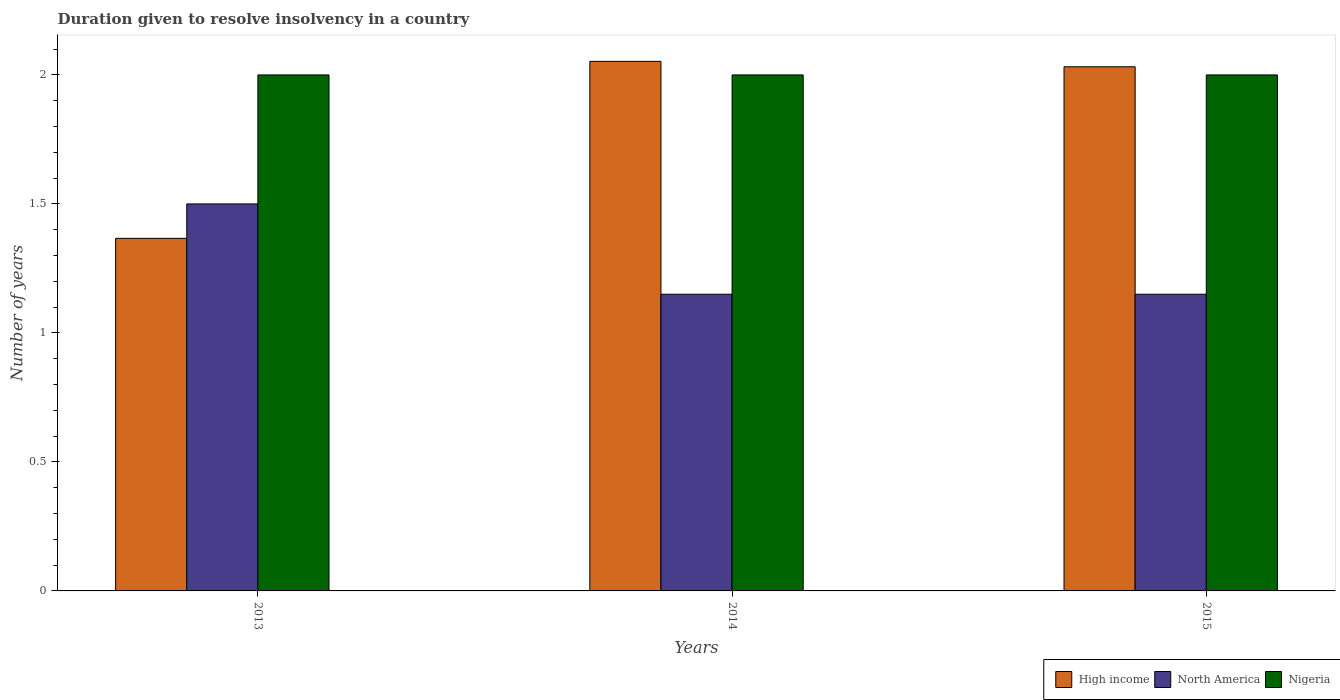How many different coloured bars are there?
Ensure brevity in your answer.  3. In how many cases, is the number of bars for a given year not equal to the number of legend labels?
Provide a succinct answer. 0. What is the duration given to resolve insolvency in in High income in 2013?
Offer a very short reply. 1.37. Across all years, what is the maximum duration given to resolve insolvency in in High income?
Offer a terse response. 2.05. Across all years, what is the minimum duration given to resolve insolvency in in North America?
Offer a terse response. 1.15. In which year was the duration given to resolve insolvency in in North America minimum?
Give a very brief answer. 2014. What is the total duration given to resolve insolvency in in Nigeria in the graph?
Offer a very short reply. 6. What is the difference between the duration given to resolve insolvency in in High income in 2013 and that in 2014?
Give a very brief answer. -0.69. What is the difference between the duration given to resolve insolvency in in North America in 2015 and the duration given to resolve insolvency in in Nigeria in 2013?
Your answer should be very brief. -0.85. What is the average duration given to resolve insolvency in in North America per year?
Keep it short and to the point. 1.27. In the year 2015, what is the difference between the duration given to resolve insolvency in in High income and duration given to resolve insolvency in in Nigeria?
Offer a terse response. 0.03. In how many years, is the duration given to resolve insolvency in in Nigeria greater than 0.9 years?
Ensure brevity in your answer.  3. What is the ratio of the duration given to resolve insolvency in in North America in 2013 to that in 2015?
Your answer should be very brief. 1.3. Is the duration given to resolve insolvency in in Nigeria in 2013 less than that in 2015?
Your answer should be compact. No. What is the difference between the highest and the second highest duration given to resolve insolvency in in High income?
Your answer should be very brief. 0.02. What is the difference between the highest and the lowest duration given to resolve insolvency in in North America?
Give a very brief answer. 0.35. Is the sum of the duration given to resolve insolvency in in High income in 2013 and 2015 greater than the maximum duration given to resolve insolvency in in Nigeria across all years?
Keep it short and to the point. Yes. What does the 2nd bar from the left in 2014 represents?
Give a very brief answer. North America. Are all the bars in the graph horizontal?
Offer a very short reply. No. How many years are there in the graph?
Your answer should be compact. 3. What is the difference between two consecutive major ticks on the Y-axis?
Make the answer very short. 0.5. Does the graph contain any zero values?
Provide a succinct answer. No. Does the graph contain grids?
Your response must be concise. No. Where does the legend appear in the graph?
Offer a terse response. Bottom right. How many legend labels are there?
Your answer should be very brief. 3. How are the legend labels stacked?
Offer a very short reply. Horizontal. What is the title of the graph?
Your answer should be very brief. Duration given to resolve insolvency in a country. What is the label or title of the X-axis?
Give a very brief answer. Years. What is the label or title of the Y-axis?
Your answer should be very brief. Number of years. What is the Number of years of High income in 2013?
Your response must be concise. 1.37. What is the Number of years of North America in 2013?
Your answer should be very brief. 1.5. What is the Number of years of High income in 2014?
Your response must be concise. 2.05. What is the Number of years in North America in 2014?
Provide a short and direct response. 1.15. What is the Number of years in Nigeria in 2014?
Your answer should be very brief. 2. What is the Number of years of High income in 2015?
Keep it short and to the point. 2.03. What is the Number of years of North America in 2015?
Provide a succinct answer. 1.15. What is the Number of years of Nigeria in 2015?
Your answer should be compact. 2. Across all years, what is the maximum Number of years of High income?
Your answer should be very brief. 2.05. Across all years, what is the maximum Number of years in North America?
Offer a very short reply. 1.5. Across all years, what is the maximum Number of years in Nigeria?
Ensure brevity in your answer.  2. Across all years, what is the minimum Number of years of High income?
Ensure brevity in your answer.  1.37. Across all years, what is the minimum Number of years of North America?
Your answer should be compact. 1.15. What is the total Number of years of High income in the graph?
Provide a short and direct response. 5.45. What is the total Number of years of North America in the graph?
Give a very brief answer. 3.8. What is the difference between the Number of years in High income in 2013 and that in 2014?
Offer a terse response. -0.69. What is the difference between the Number of years of High income in 2013 and that in 2015?
Offer a terse response. -0.66. What is the difference between the Number of years in High income in 2014 and that in 2015?
Make the answer very short. 0.02. What is the difference between the Number of years in Nigeria in 2014 and that in 2015?
Your answer should be compact. 0. What is the difference between the Number of years of High income in 2013 and the Number of years of North America in 2014?
Your answer should be compact. 0.22. What is the difference between the Number of years of High income in 2013 and the Number of years of Nigeria in 2014?
Provide a succinct answer. -0.63. What is the difference between the Number of years in North America in 2013 and the Number of years in Nigeria in 2014?
Offer a very short reply. -0.5. What is the difference between the Number of years of High income in 2013 and the Number of years of North America in 2015?
Keep it short and to the point. 0.22. What is the difference between the Number of years in High income in 2013 and the Number of years in Nigeria in 2015?
Provide a short and direct response. -0.63. What is the difference between the Number of years in High income in 2014 and the Number of years in North America in 2015?
Ensure brevity in your answer.  0.9. What is the difference between the Number of years of High income in 2014 and the Number of years of Nigeria in 2015?
Ensure brevity in your answer.  0.05. What is the difference between the Number of years of North America in 2014 and the Number of years of Nigeria in 2015?
Your response must be concise. -0.85. What is the average Number of years in High income per year?
Give a very brief answer. 1.82. What is the average Number of years of North America per year?
Make the answer very short. 1.27. What is the average Number of years of Nigeria per year?
Make the answer very short. 2. In the year 2013, what is the difference between the Number of years of High income and Number of years of North America?
Provide a short and direct response. -0.13. In the year 2013, what is the difference between the Number of years of High income and Number of years of Nigeria?
Keep it short and to the point. -0.63. In the year 2013, what is the difference between the Number of years of North America and Number of years of Nigeria?
Ensure brevity in your answer.  -0.5. In the year 2014, what is the difference between the Number of years of High income and Number of years of North America?
Offer a very short reply. 0.9. In the year 2014, what is the difference between the Number of years of High income and Number of years of Nigeria?
Give a very brief answer. 0.05. In the year 2014, what is the difference between the Number of years in North America and Number of years in Nigeria?
Provide a short and direct response. -0.85. In the year 2015, what is the difference between the Number of years of High income and Number of years of North America?
Offer a terse response. 0.88. In the year 2015, what is the difference between the Number of years in High income and Number of years in Nigeria?
Provide a short and direct response. 0.03. In the year 2015, what is the difference between the Number of years in North America and Number of years in Nigeria?
Provide a short and direct response. -0.85. What is the ratio of the Number of years of High income in 2013 to that in 2014?
Make the answer very short. 0.67. What is the ratio of the Number of years in North America in 2013 to that in 2014?
Your response must be concise. 1.3. What is the ratio of the Number of years in High income in 2013 to that in 2015?
Your response must be concise. 0.67. What is the ratio of the Number of years of North America in 2013 to that in 2015?
Offer a terse response. 1.3. What is the ratio of the Number of years in Nigeria in 2013 to that in 2015?
Keep it short and to the point. 1. What is the ratio of the Number of years in High income in 2014 to that in 2015?
Your answer should be compact. 1.01. What is the difference between the highest and the second highest Number of years in High income?
Keep it short and to the point. 0.02. What is the difference between the highest and the second highest Number of years of North America?
Give a very brief answer. 0.35. What is the difference between the highest and the lowest Number of years in High income?
Ensure brevity in your answer.  0.69. What is the difference between the highest and the lowest Number of years of North America?
Ensure brevity in your answer.  0.35. 